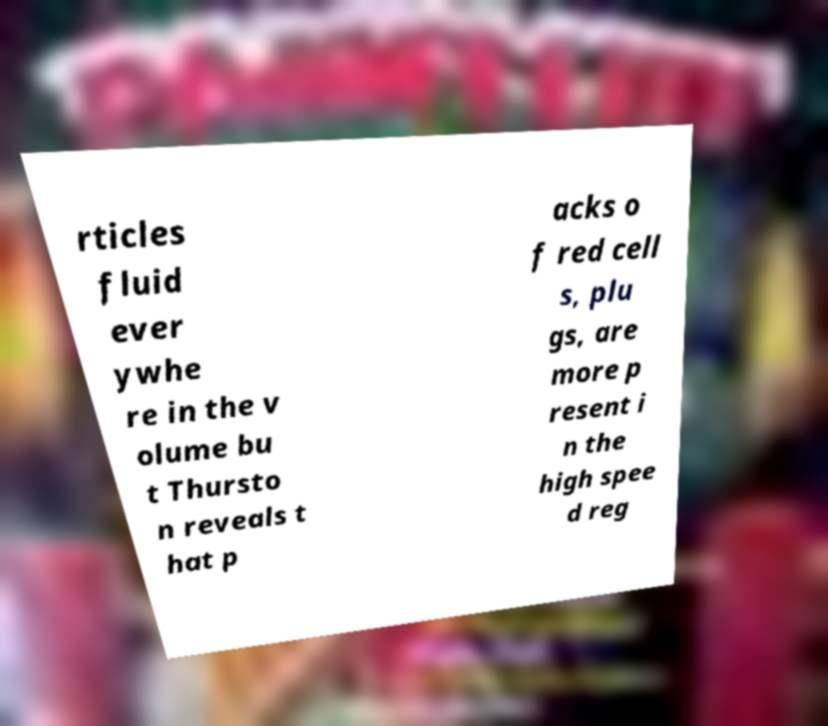There's text embedded in this image that I need extracted. Can you transcribe it verbatim? rticles fluid ever ywhe re in the v olume bu t Thursto n reveals t hat p acks o f red cell s, plu gs, are more p resent i n the high spee d reg 